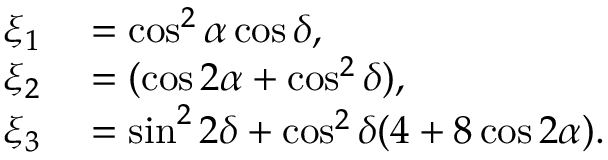Convert formula to latex. <formula><loc_0><loc_0><loc_500><loc_500>\begin{array} { r l } { \xi _ { 1 } } & = \cos ^ { 2 } \alpha \cos \delta , } \\ { \xi _ { 2 } } & = ( \cos 2 \alpha + \cos ^ { 2 } \delta ) , } \\ { \xi _ { 3 } } & = \sin ^ { 2 } 2 \delta + \cos ^ { 2 } \delta ( 4 + 8 \cos 2 \alpha ) . } \end{array}</formula> 